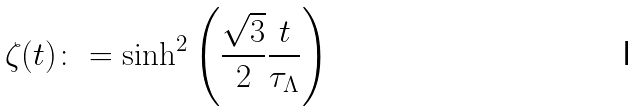Convert formula to latex. <formula><loc_0><loc_0><loc_500><loc_500>\zeta ( t ) \colon = \sinh ^ { 2 } \left ( \frac { \sqrt { 3 } } { 2 } \frac { t } { \tau _ { \Lambda } } \right )</formula> 